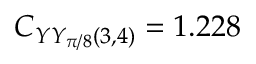Convert formula to latex. <formula><loc_0><loc_0><loc_500><loc_500>C _ { Y Y _ { \pi / 8 } ( 3 , 4 ) } = 1 . 2 2 8</formula> 